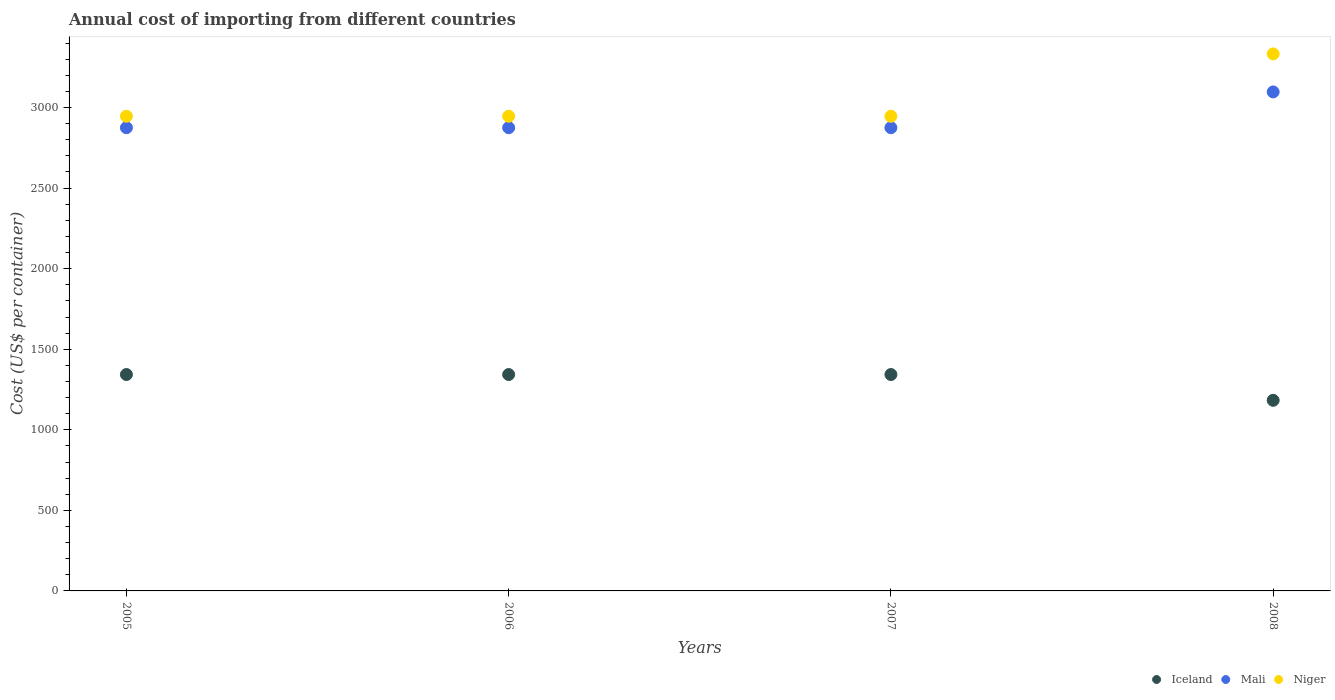How many different coloured dotlines are there?
Offer a terse response. 3. What is the total annual cost of importing in Iceland in 2006?
Offer a terse response. 1343. Across all years, what is the maximum total annual cost of importing in Mali?
Your response must be concise. 3097. Across all years, what is the minimum total annual cost of importing in Niger?
Make the answer very short. 2946. In which year was the total annual cost of importing in Niger maximum?
Your answer should be very brief. 2008. In which year was the total annual cost of importing in Niger minimum?
Offer a terse response. 2005. What is the total total annual cost of importing in Niger in the graph?
Your response must be concise. 1.22e+04. What is the difference between the total annual cost of importing in Mali in 2005 and that in 2006?
Your response must be concise. 0. What is the difference between the total annual cost of importing in Niger in 2005 and the total annual cost of importing in Iceland in 2007?
Ensure brevity in your answer.  1603. What is the average total annual cost of importing in Mali per year?
Ensure brevity in your answer.  2930.5. In the year 2008, what is the difference between the total annual cost of importing in Mali and total annual cost of importing in Niger?
Provide a succinct answer. -236. Is the difference between the total annual cost of importing in Mali in 2006 and 2007 greater than the difference between the total annual cost of importing in Niger in 2006 and 2007?
Keep it short and to the point. No. What is the difference between the highest and the second highest total annual cost of importing in Mali?
Your response must be concise. 222. What is the difference between the highest and the lowest total annual cost of importing in Iceland?
Provide a succinct answer. 160. In how many years, is the total annual cost of importing in Mali greater than the average total annual cost of importing in Mali taken over all years?
Keep it short and to the point. 1. Is the sum of the total annual cost of importing in Iceland in 2006 and 2007 greater than the maximum total annual cost of importing in Niger across all years?
Your response must be concise. No. Is the total annual cost of importing in Iceland strictly greater than the total annual cost of importing in Mali over the years?
Your answer should be very brief. No. Is the total annual cost of importing in Mali strictly less than the total annual cost of importing in Niger over the years?
Your answer should be very brief. Yes. How many dotlines are there?
Ensure brevity in your answer.  3. What is the difference between two consecutive major ticks on the Y-axis?
Provide a short and direct response. 500. Are the values on the major ticks of Y-axis written in scientific E-notation?
Your response must be concise. No. Does the graph contain any zero values?
Offer a very short reply. No. Does the graph contain grids?
Offer a terse response. No. How are the legend labels stacked?
Provide a short and direct response. Horizontal. What is the title of the graph?
Keep it short and to the point. Annual cost of importing from different countries. Does "Nigeria" appear as one of the legend labels in the graph?
Your answer should be very brief. No. What is the label or title of the Y-axis?
Provide a short and direct response. Cost (US$ per container). What is the Cost (US$ per container) of Iceland in 2005?
Give a very brief answer. 1343. What is the Cost (US$ per container) in Mali in 2005?
Make the answer very short. 2875. What is the Cost (US$ per container) of Niger in 2005?
Offer a terse response. 2946. What is the Cost (US$ per container) in Iceland in 2006?
Your answer should be compact. 1343. What is the Cost (US$ per container) of Mali in 2006?
Ensure brevity in your answer.  2875. What is the Cost (US$ per container) in Niger in 2006?
Ensure brevity in your answer.  2946. What is the Cost (US$ per container) of Iceland in 2007?
Ensure brevity in your answer.  1343. What is the Cost (US$ per container) in Mali in 2007?
Offer a very short reply. 2875. What is the Cost (US$ per container) of Niger in 2007?
Ensure brevity in your answer.  2946. What is the Cost (US$ per container) in Iceland in 2008?
Keep it short and to the point. 1183. What is the Cost (US$ per container) in Mali in 2008?
Make the answer very short. 3097. What is the Cost (US$ per container) in Niger in 2008?
Offer a terse response. 3333. Across all years, what is the maximum Cost (US$ per container) in Iceland?
Provide a short and direct response. 1343. Across all years, what is the maximum Cost (US$ per container) in Mali?
Your answer should be very brief. 3097. Across all years, what is the maximum Cost (US$ per container) in Niger?
Offer a terse response. 3333. Across all years, what is the minimum Cost (US$ per container) of Iceland?
Ensure brevity in your answer.  1183. Across all years, what is the minimum Cost (US$ per container) of Mali?
Make the answer very short. 2875. Across all years, what is the minimum Cost (US$ per container) of Niger?
Your answer should be very brief. 2946. What is the total Cost (US$ per container) of Iceland in the graph?
Your response must be concise. 5212. What is the total Cost (US$ per container) of Mali in the graph?
Your response must be concise. 1.17e+04. What is the total Cost (US$ per container) of Niger in the graph?
Make the answer very short. 1.22e+04. What is the difference between the Cost (US$ per container) of Iceland in 2005 and that in 2006?
Provide a succinct answer. 0. What is the difference between the Cost (US$ per container) in Mali in 2005 and that in 2006?
Give a very brief answer. 0. What is the difference between the Cost (US$ per container) of Niger in 2005 and that in 2006?
Your answer should be very brief. 0. What is the difference between the Cost (US$ per container) of Iceland in 2005 and that in 2007?
Provide a succinct answer. 0. What is the difference between the Cost (US$ per container) of Mali in 2005 and that in 2007?
Give a very brief answer. 0. What is the difference between the Cost (US$ per container) of Iceland in 2005 and that in 2008?
Provide a short and direct response. 160. What is the difference between the Cost (US$ per container) in Mali in 2005 and that in 2008?
Your answer should be compact. -222. What is the difference between the Cost (US$ per container) in Niger in 2005 and that in 2008?
Give a very brief answer. -387. What is the difference between the Cost (US$ per container) in Mali in 2006 and that in 2007?
Ensure brevity in your answer.  0. What is the difference between the Cost (US$ per container) of Niger in 2006 and that in 2007?
Ensure brevity in your answer.  0. What is the difference between the Cost (US$ per container) in Iceland in 2006 and that in 2008?
Ensure brevity in your answer.  160. What is the difference between the Cost (US$ per container) in Mali in 2006 and that in 2008?
Give a very brief answer. -222. What is the difference between the Cost (US$ per container) of Niger in 2006 and that in 2008?
Provide a succinct answer. -387. What is the difference between the Cost (US$ per container) in Iceland in 2007 and that in 2008?
Make the answer very short. 160. What is the difference between the Cost (US$ per container) of Mali in 2007 and that in 2008?
Your answer should be compact. -222. What is the difference between the Cost (US$ per container) of Niger in 2007 and that in 2008?
Offer a very short reply. -387. What is the difference between the Cost (US$ per container) in Iceland in 2005 and the Cost (US$ per container) in Mali in 2006?
Keep it short and to the point. -1532. What is the difference between the Cost (US$ per container) in Iceland in 2005 and the Cost (US$ per container) in Niger in 2006?
Provide a succinct answer. -1603. What is the difference between the Cost (US$ per container) of Mali in 2005 and the Cost (US$ per container) of Niger in 2006?
Offer a terse response. -71. What is the difference between the Cost (US$ per container) in Iceland in 2005 and the Cost (US$ per container) in Mali in 2007?
Make the answer very short. -1532. What is the difference between the Cost (US$ per container) in Iceland in 2005 and the Cost (US$ per container) in Niger in 2007?
Your answer should be compact. -1603. What is the difference between the Cost (US$ per container) of Mali in 2005 and the Cost (US$ per container) of Niger in 2007?
Offer a very short reply. -71. What is the difference between the Cost (US$ per container) of Iceland in 2005 and the Cost (US$ per container) of Mali in 2008?
Keep it short and to the point. -1754. What is the difference between the Cost (US$ per container) in Iceland in 2005 and the Cost (US$ per container) in Niger in 2008?
Keep it short and to the point. -1990. What is the difference between the Cost (US$ per container) in Mali in 2005 and the Cost (US$ per container) in Niger in 2008?
Ensure brevity in your answer.  -458. What is the difference between the Cost (US$ per container) in Iceland in 2006 and the Cost (US$ per container) in Mali in 2007?
Ensure brevity in your answer.  -1532. What is the difference between the Cost (US$ per container) in Iceland in 2006 and the Cost (US$ per container) in Niger in 2007?
Make the answer very short. -1603. What is the difference between the Cost (US$ per container) in Mali in 2006 and the Cost (US$ per container) in Niger in 2007?
Your response must be concise. -71. What is the difference between the Cost (US$ per container) in Iceland in 2006 and the Cost (US$ per container) in Mali in 2008?
Your answer should be compact. -1754. What is the difference between the Cost (US$ per container) of Iceland in 2006 and the Cost (US$ per container) of Niger in 2008?
Ensure brevity in your answer.  -1990. What is the difference between the Cost (US$ per container) in Mali in 2006 and the Cost (US$ per container) in Niger in 2008?
Your answer should be very brief. -458. What is the difference between the Cost (US$ per container) in Iceland in 2007 and the Cost (US$ per container) in Mali in 2008?
Give a very brief answer. -1754. What is the difference between the Cost (US$ per container) in Iceland in 2007 and the Cost (US$ per container) in Niger in 2008?
Your answer should be very brief. -1990. What is the difference between the Cost (US$ per container) of Mali in 2007 and the Cost (US$ per container) of Niger in 2008?
Keep it short and to the point. -458. What is the average Cost (US$ per container) of Iceland per year?
Offer a terse response. 1303. What is the average Cost (US$ per container) of Mali per year?
Your response must be concise. 2930.5. What is the average Cost (US$ per container) in Niger per year?
Keep it short and to the point. 3042.75. In the year 2005, what is the difference between the Cost (US$ per container) of Iceland and Cost (US$ per container) of Mali?
Your response must be concise. -1532. In the year 2005, what is the difference between the Cost (US$ per container) of Iceland and Cost (US$ per container) of Niger?
Offer a very short reply. -1603. In the year 2005, what is the difference between the Cost (US$ per container) in Mali and Cost (US$ per container) in Niger?
Your response must be concise. -71. In the year 2006, what is the difference between the Cost (US$ per container) in Iceland and Cost (US$ per container) in Mali?
Make the answer very short. -1532. In the year 2006, what is the difference between the Cost (US$ per container) in Iceland and Cost (US$ per container) in Niger?
Keep it short and to the point. -1603. In the year 2006, what is the difference between the Cost (US$ per container) in Mali and Cost (US$ per container) in Niger?
Ensure brevity in your answer.  -71. In the year 2007, what is the difference between the Cost (US$ per container) of Iceland and Cost (US$ per container) of Mali?
Offer a terse response. -1532. In the year 2007, what is the difference between the Cost (US$ per container) of Iceland and Cost (US$ per container) of Niger?
Give a very brief answer. -1603. In the year 2007, what is the difference between the Cost (US$ per container) of Mali and Cost (US$ per container) of Niger?
Ensure brevity in your answer.  -71. In the year 2008, what is the difference between the Cost (US$ per container) in Iceland and Cost (US$ per container) in Mali?
Make the answer very short. -1914. In the year 2008, what is the difference between the Cost (US$ per container) in Iceland and Cost (US$ per container) in Niger?
Your answer should be compact. -2150. In the year 2008, what is the difference between the Cost (US$ per container) in Mali and Cost (US$ per container) in Niger?
Provide a succinct answer. -236. What is the ratio of the Cost (US$ per container) in Mali in 2005 to that in 2006?
Make the answer very short. 1. What is the ratio of the Cost (US$ per container) in Iceland in 2005 to that in 2007?
Your response must be concise. 1. What is the ratio of the Cost (US$ per container) in Mali in 2005 to that in 2007?
Ensure brevity in your answer.  1. What is the ratio of the Cost (US$ per container) in Iceland in 2005 to that in 2008?
Keep it short and to the point. 1.14. What is the ratio of the Cost (US$ per container) in Mali in 2005 to that in 2008?
Ensure brevity in your answer.  0.93. What is the ratio of the Cost (US$ per container) in Niger in 2005 to that in 2008?
Offer a very short reply. 0.88. What is the ratio of the Cost (US$ per container) of Iceland in 2006 to that in 2007?
Your response must be concise. 1. What is the ratio of the Cost (US$ per container) of Mali in 2006 to that in 2007?
Your answer should be compact. 1. What is the ratio of the Cost (US$ per container) in Iceland in 2006 to that in 2008?
Make the answer very short. 1.14. What is the ratio of the Cost (US$ per container) of Mali in 2006 to that in 2008?
Your answer should be very brief. 0.93. What is the ratio of the Cost (US$ per container) in Niger in 2006 to that in 2008?
Provide a succinct answer. 0.88. What is the ratio of the Cost (US$ per container) of Iceland in 2007 to that in 2008?
Give a very brief answer. 1.14. What is the ratio of the Cost (US$ per container) of Mali in 2007 to that in 2008?
Offer a terse response. 0.93. What is the ratio of the Cost (US$ per container) in Niger in 2007 to that in 2008?
Give a very brief answer. 0.88. What is the difference between the highest and the second highest Cost (US$ per container) in Mali?
Your response must be concise. 222. What is the difference between the highest and the second highest Cost (US$ per container) of Niger?
Offer a very short reply. 387. What is the difference between the highest and the lowest Cost (US$ per container) in Iceland?
Provide a short and direct response. 160. What is the difference between the highest and the lowest Cost (US$ per container) in Mali?
Your answer should be compact. 222. What is the difference between the highest and the lowest Cost (US$ per container) in Niger?
Offer a terse response. 387. 